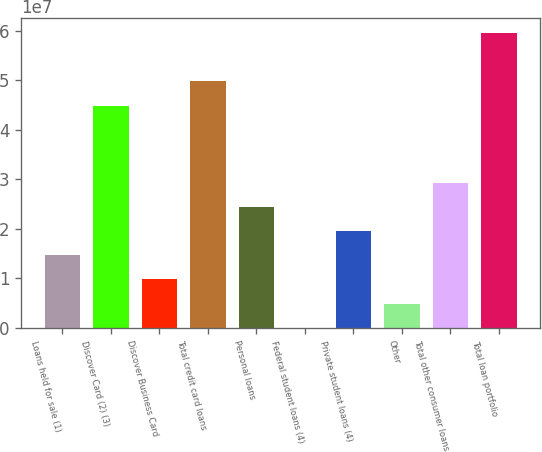<chart> <loc_0><loc_0><loc_500><loc_500><bar_chart><fcel>Loans held for sale (1)<fcel>Discover Card (2) (3)<fcel>Discover Business Card<fcel>Total credit card loans<fcel>Personal loans<fcel>Federal student loans (4)<fcel>Private student loans (4)<fcel>Other<fcel>Total other consumer loans<fcel>Total loan portfolio<nl><fcel>1.46509e+07<fcel>4.49043e+07<fcel>9.76729e+06<fcel>4.97879e+07<fcel>2.44182e+07<fcel>3.14<fcel>1.95346e+07<fcel>4.88364e+06<fcel>2.93018e+07<fcel>5.95552e+07<nl></chart> 